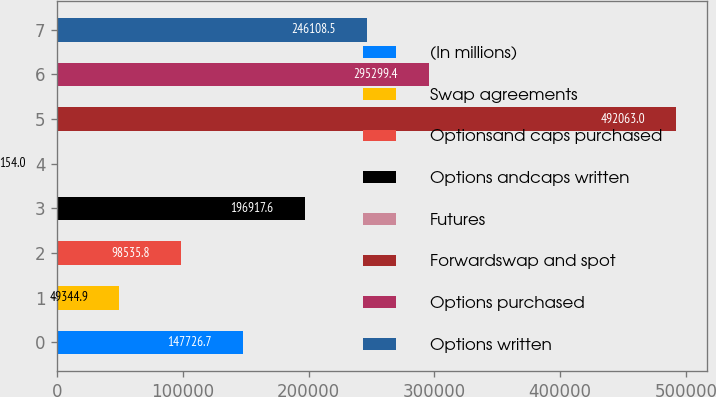Convert chart to OTSL. <chart><loc_0><loc_0><loc_500><loc_500><bar_chart><fcel>(In millions)<fcel>Swap agreements<fcel>Optionsand caps purchased<fcel>Options andcaps written<fcel>Futures<fcel>Forwardswap and spot<fcel>Options purchased<fcel>Options written<nl><fcel>147727<fcel>49344.9<fcel>98535.8<fcel>196918<fcel>154<fcel>492063<fcel>295299<fcel>246108<nl></chart> 